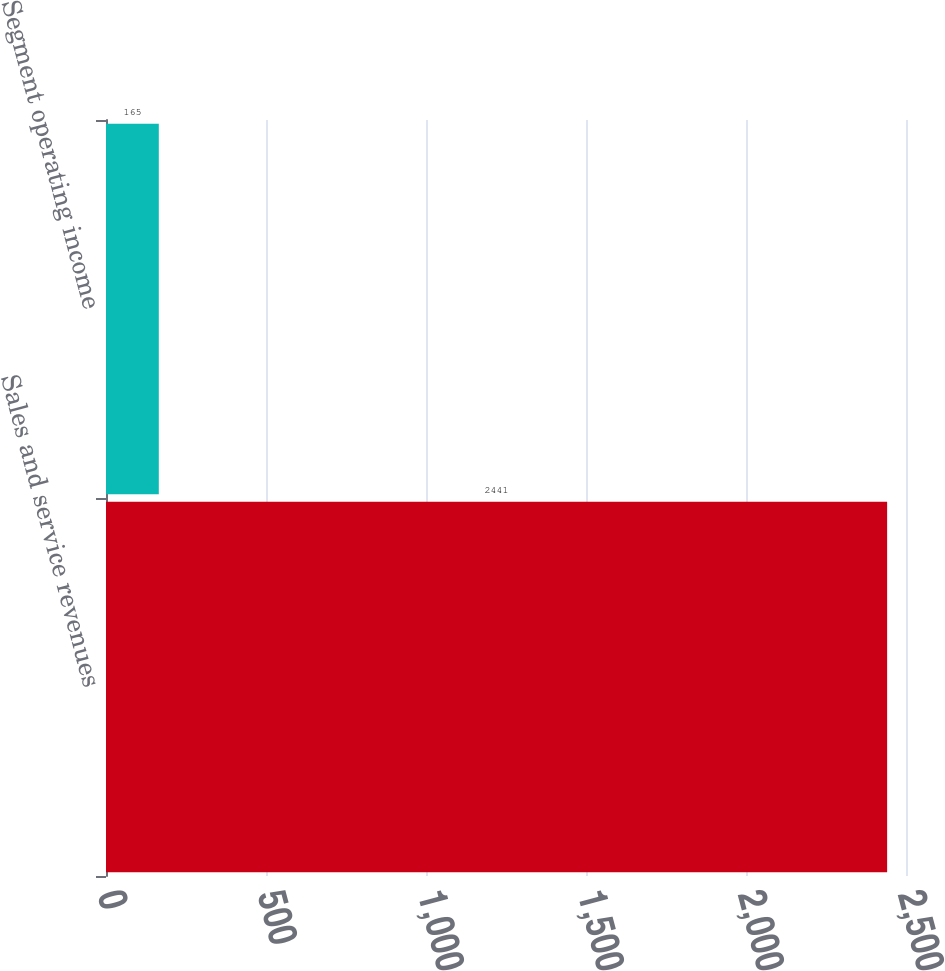<chart> <loc_0><loc_0><loc_500><loc_500><bar_chart><fcel>Sales and service revenues<fcel>Segment operating income<nl><fcel>2441<fcel>165<nl></chart> 